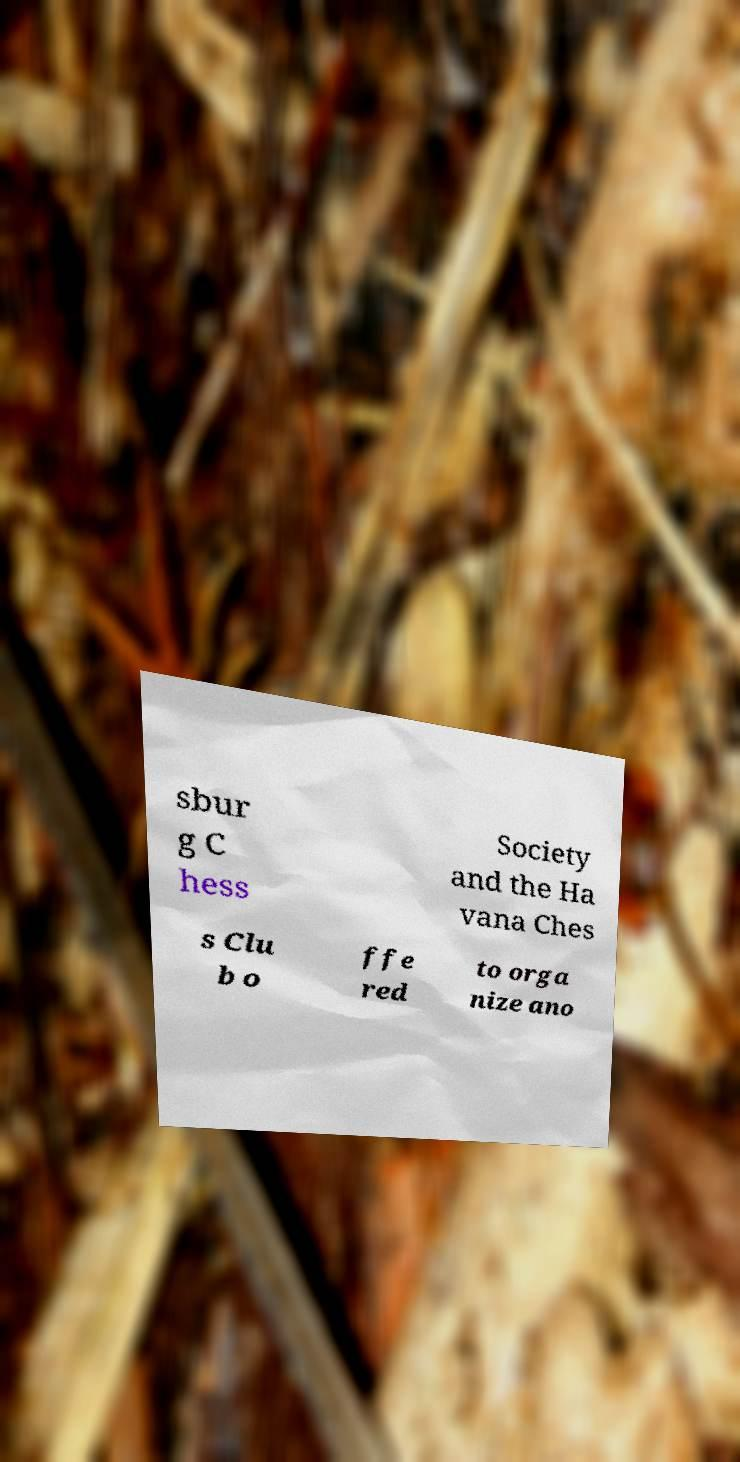Can you read and provide the text displayed in the image?This photo seems to have some interesting text. Can you extract and type it out for me? sbur g C hess Society and the Ha vana Ches s Clu b o ffe red to orga nize ano 